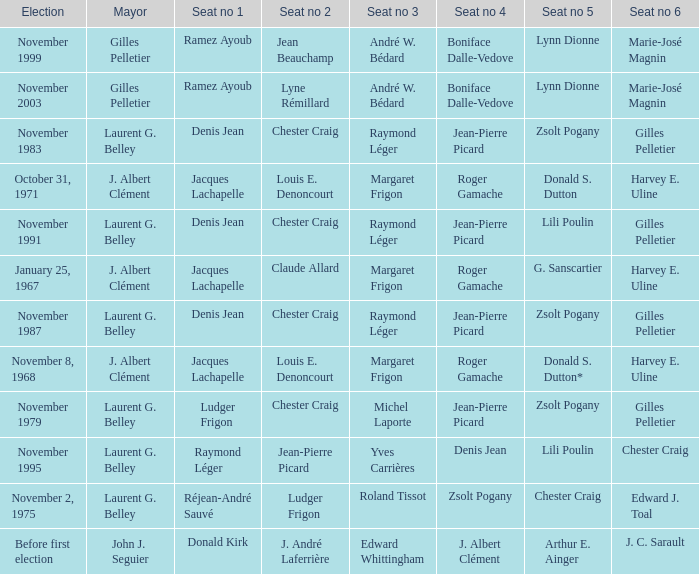Who was the winner of seat no 4 for the election on January 25, 1967 Roger Gamache. 